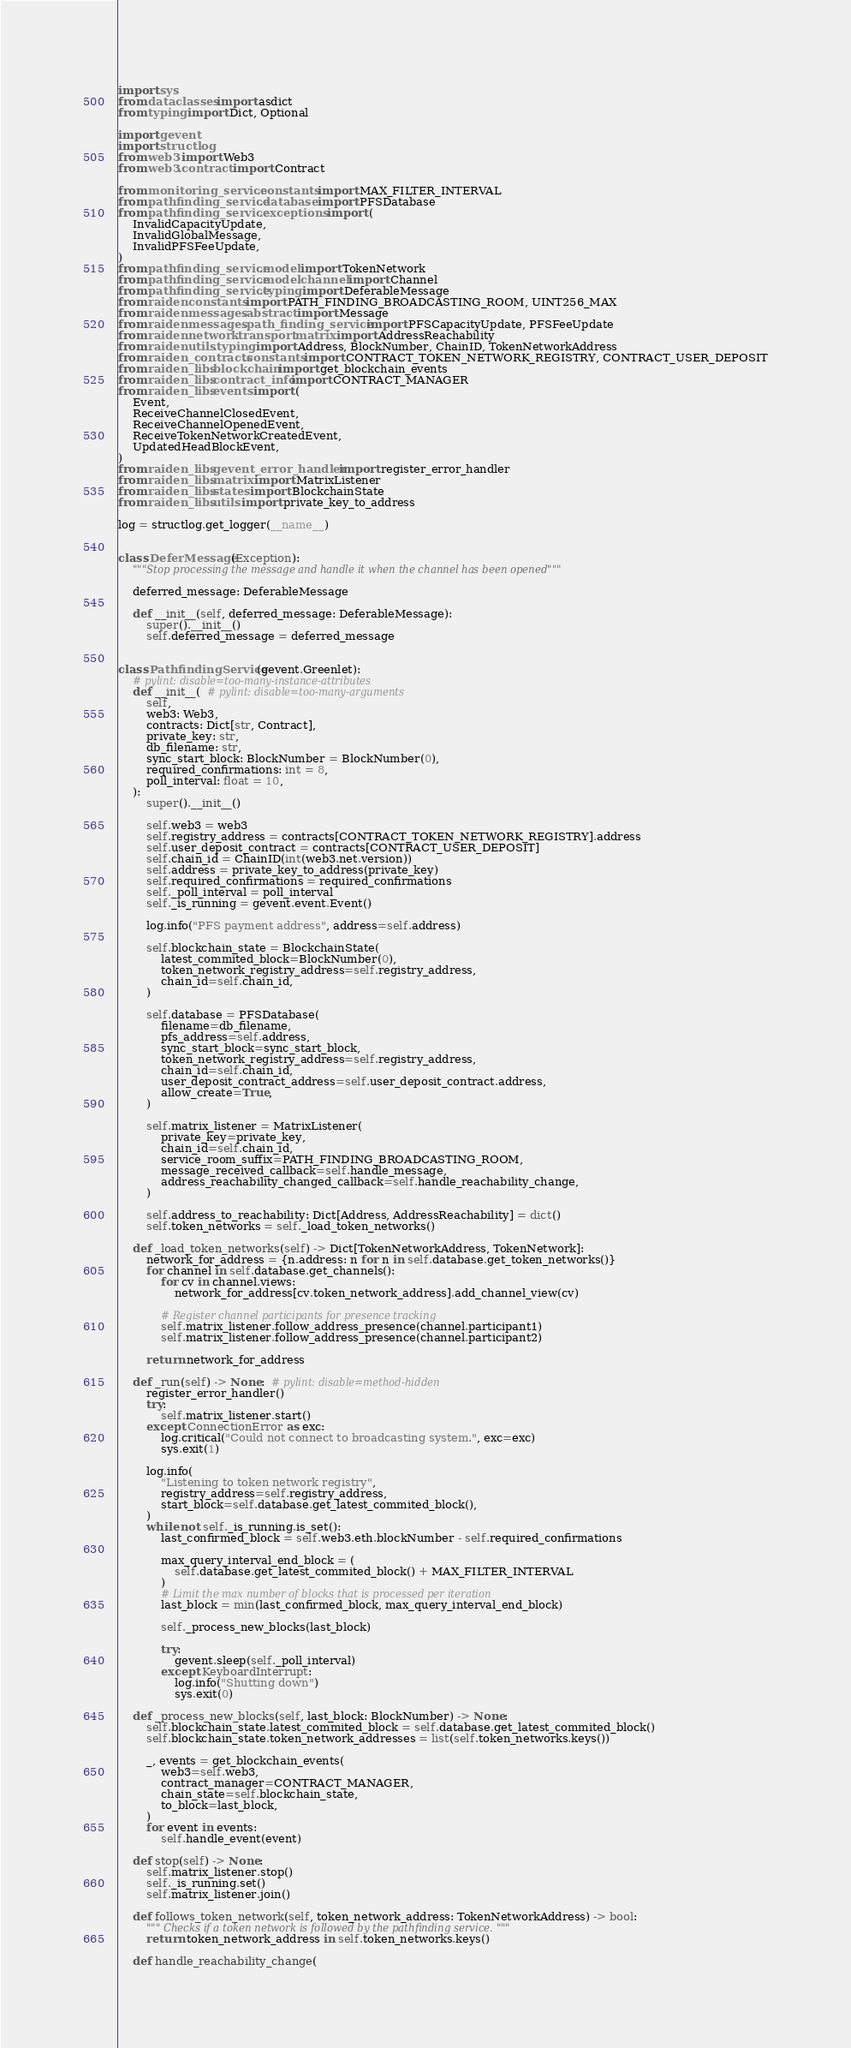Convert code to text. <code><loc_0><loc_0><loc_500><loc_500><_Python_>import sys
from dataclasses import asdict
from typing import Dict, Optional

import gevent
import structlog
from web3 import Web3
from web3.contract import Contract

from monitoring_service.constants import MAX_FILTER_INTERVAL
from pathfinding_service.database import PFSDatabase
from pathfinding_service.exceptions import (
    InvalidCapacityUpdate,
    InvalidGlobalMessage,
    InvalidPFSFeeUpdate,
)
from pathfinding_service.model import TokenNetwork
from pathfinding_service.model.channel import Channel
from pathfinding_service.typing import DeferableMessage
from raiden.constants import PATH_FINDING_BROADCASTING_ROOM, UINT256_MAX
from raiden.messages.abstract import Message
from raiden.messages.path_finding_service import PFSCapacityUpdate, PFSFeeUpdate
from raiden.network.transport.matrix import AddressReachability
from raiden.utils.typing import Address, BlockNumber, ChainID, TokenNetworkAddress
from raiden_contracts.constants import CONTRACT_TOKEN_NETWORK_REGISTRY, CONTRACT_USER_DEPOSIT
from raiden_libs.blockchain import get_blockchain_events
from raiden_libs.contract_info import CONTRACT_MANAGER
from raiden_libs.events import (
    Event,
    ReceiveChannelClosedEvent,
    ReceiveChannelOpenedEvent,
    ReceiveTokenNetworkCreatedEvent,
    UpdatedHeadBlockEvent,
)
from raiden_libs.gevent_error_handler import register_error_handler
from raiden_libs.matrix import MatrixListener
from raiden_libs.states import BlockchainState
from raiden_libs.utils import private_key_to_address

log = structlog.get_logger(__name__)


class DeferMessage(Exception):
    """Stop processing the message and handle it when the channel has been opened"""

    deferred_message: DeferableMessage

    def __init__(self, deferred_message: DeferableMessage):
        super().__init__()
        self.deferred_message = deferred_message


class PathfindingService(gevent.Greenlet):
    # pylint: disable=too-many-instance-attributes
    def __init__(  # pylint: disable=too-many-arguments
        self,
        web3: Web3,
        contracts: Dict[str, Contract],
        private_key: str,
        db_filename: str,
        sync_start_block: BlockNumber = BlockNumber(0),
        required_confirmations: int = 8,
        poll_interval: float = 10,
    ):
        super().__init__()

        self.web3 = web3
        self.registry_address = contracts[CONTRACT_TOKEN_NETWORK_REGISTRY].address
        self.user_deposit_contract = contracts[CONTRACT_USER_DEPOSIT]
        self.chain_id = ChainID(int(web3.net.version))
        self.address = private_key_to_address(private_key)
        self.required_confirmations = required_confirmations
        self._poll_interval = poll_interval
        self._is_running = gevent.event.Event()

        log.info("PFS payment address", address=self.address)

        self.blockchain_state = BlockchainState(
            latest_commited_block=BlockNumber(0),
            token_network_registry_address=self.registry_address,
            chain_id=self.chain_id,
        )

        self.database = PFSDatabase(
            filename=db_filename,
            pfs_address=self.address,
            sync_start_block=sync_start_block,
            token_network_registry_address=self.registry_address,
            chain_id=self.chain_id,
            user_deposit_contract_address=self.user_deposit_contract.address,
            allow_create=True,
        )

        self.matrix_listener = MatrixListener(
            private_key=private_key,
            chain_id=self.chain_id,
            service_room_suffix=PATH_FINDING_BROADCASTING_ROOM,
            message_received_callback=self.handle_message,
            address_reachability_changed_callback=self.handle_reachability_change,
        )

        self.address_to_reachability: Dict[Address, AddressReachability] = dict()
        self.token_networks = self._load_token_networks()

    def _load_token_networks(self) -> Dict[TokenNetworkAddress, TokenNetwork]:
        network_for_address = {n.address: n for n in self.database.get_token_networks()}
        for channel in self.database.get_channels():
            for cv in channel.views:
                network_for_address[cv.token_network_address].add_channel_view(cv)

            # Register channel participants for presence tracking
            self.matrix_listener.follow_address_presence(channel.participant1)
            self.matrix_listener.follow_address_presence(channel.participant2)

        return network_for_address

    def _run(self) -> None:  # pylint: disable=method-hidden
        register_error_handler()
        try:
            self.matrix_listener.start()
        except ConnectionError as exc:
            log.critical("Could not connect to broadcasting system.", exc=exc)
            sys.exit(1)

        log.info(
            "Listening to token network registry",
            registry_address=self.registry_address,
            start_block=self.database.get_latest_commited_block(),
        )
        while not self._is_running.is_set():
            last_confirmed_block = self.web3.eth.blockNumber - self.required_confirmations

            max_query_interval_end_block = (
                self.database.get_latest_commited_block() + MAX_FILTER_INTERVAL
            )
            # Limit the max number of blocks that is processed per iteration
            last_block = min(last_confirmed_block, max_query_interval_end_block)

            self._process_new_blocks(last_block)

            try:
                gevent.sleep(self._poll_interval)
            except KeyboardInterrupt:
                log.info("Shutting down")
                sys.exit(0)

    def _process_new_blocks(self, last_block: BlockNumber) -> None:
        self.blockchain_state.latest_commited_block = self.database.get_latest_commited_block()
        self.blockchain_state.token_network_addresses = list(self.token_networks.keys())

        _, events = get_blockchain_events(
            web3=self.web3,
            contract_manager=CONTRACT_MANAGER,
            chain_state=self.blockchain_state,
            to_block=last_block,
        )
        for event in events:
            self.handle_event(event)

    def stop(self) -> None:
        self.matrix_listener.stop()
        self._is_running.set()
        self.matrix_listener.join()

    def follows_token_network(self, token_network_address: TokenNetworkAddress) -> bool:
        """ Checks if a token network is followed by the pathfinding service. """
        return token_network_address in self.token_networks.keys()

    def handle_reachability_change(</code> 